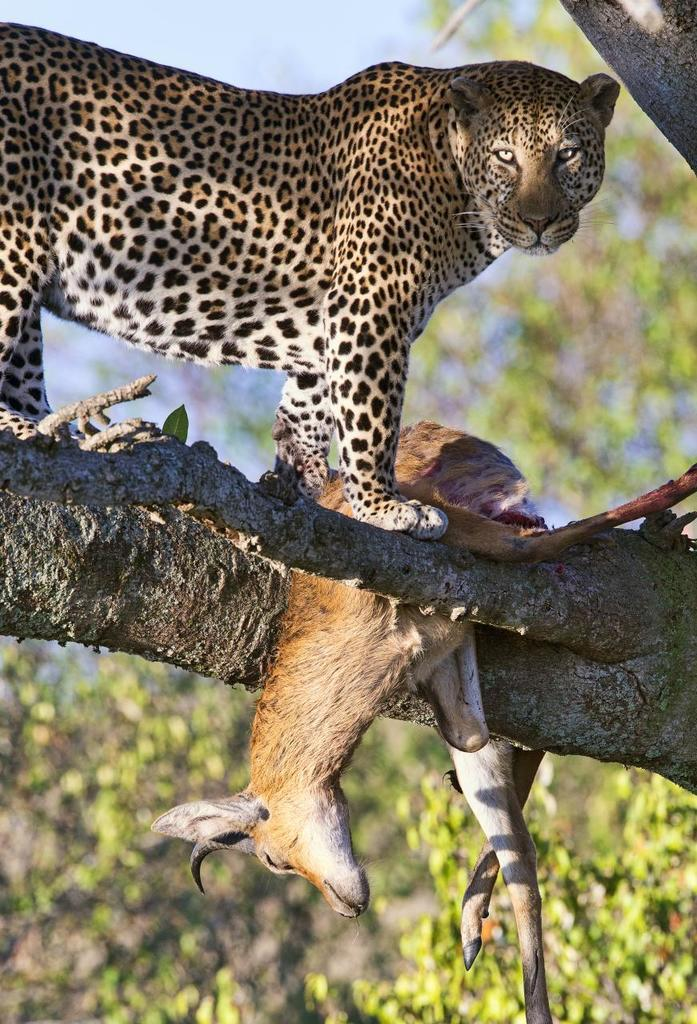What animals can be seen in the image? There is a leopard and a deer in the image. Where are the leopard and deer located? The leopard and deer are on a tree in the image. What can be seen in the background of the image? There are trees visible in the background of the image. What type of sleet can be seen falling from the sky in the image? There is no sleet present in the image; it is a clear day with no precipitation. How does the behavior of the leopard and deer change throughout the day in the image? The image is a still photograph, so it does not show any changes in behavior over time. 